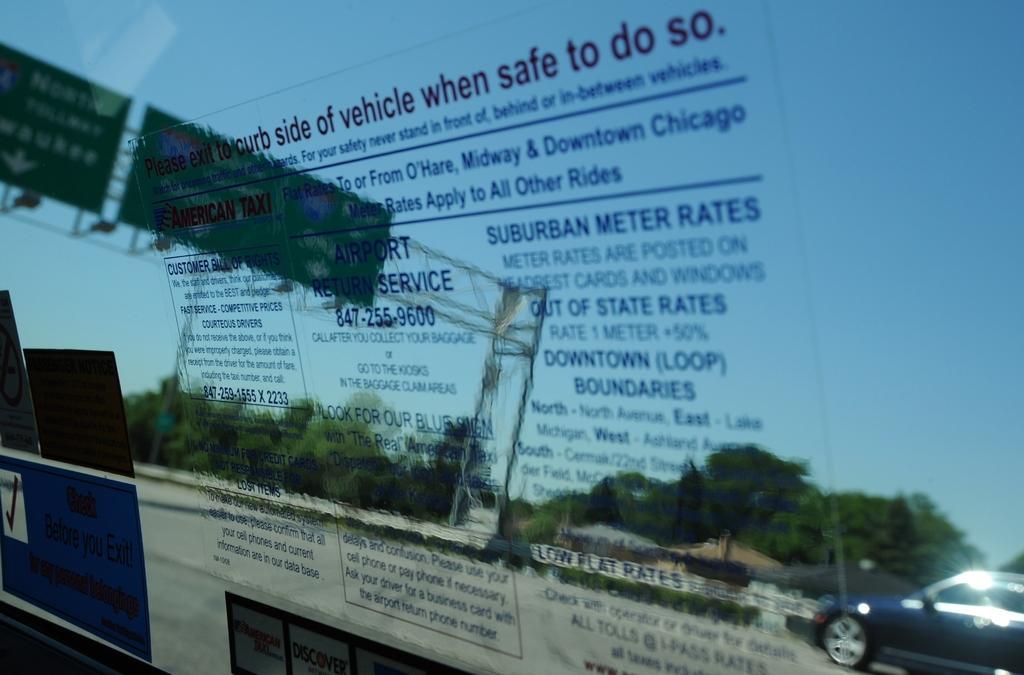Please provide a concise description of this image. In this image, we can see poster on the glass. Through the glass, we can see trees, vehicles, road, rods, boards and sky. 